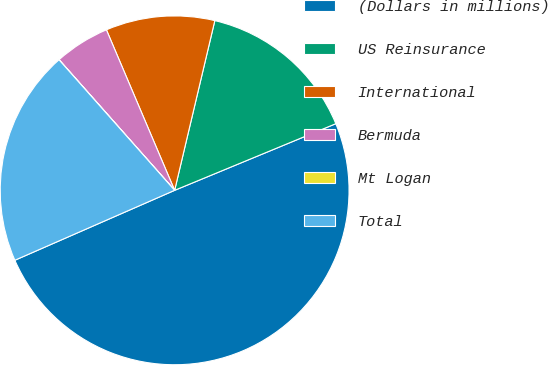Convert chart. <chart><loc_0><loc_0><loc_500><loc_500><pie_chart><fcel>(Dollars in millions)<fcel>US Reinsurance<fcel>International<fcel>Bermuda<fcel>Mt Logan<fcel>Total<nl><fcel>49.68%<fcel>15.06%<fcel>10.1%<fcel>5.13%<fcel>0.01%<fcel>20.03%<nl></chart> 